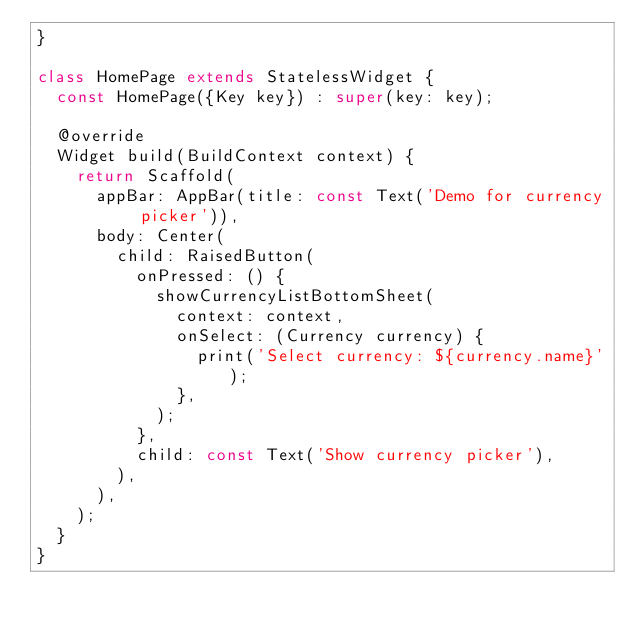Convert code to text. <code><loc_0><loc_0><loc_500><loc_500><_Dart_>}

class HomePage extends StatelessWidget {
  const HomePage({Key key}) : super(key: key);

  @override
  Widget build(BuildContext context) {
    return Scaffold(
      appBar: AppBar(title: const Text('Demo for currency picker')),
      body: Center(
        child: RaisedButton(
          onPressed: () {
            showCurrencyListBottomSheet(
              context: context,
              onSelect: (Currency currency) {
                print('Select currency: ${currency.name}');
              },
            );
          },
          child: const Text('Show currency picker'),
        ),
      ),
    );
  }
}
</code> 